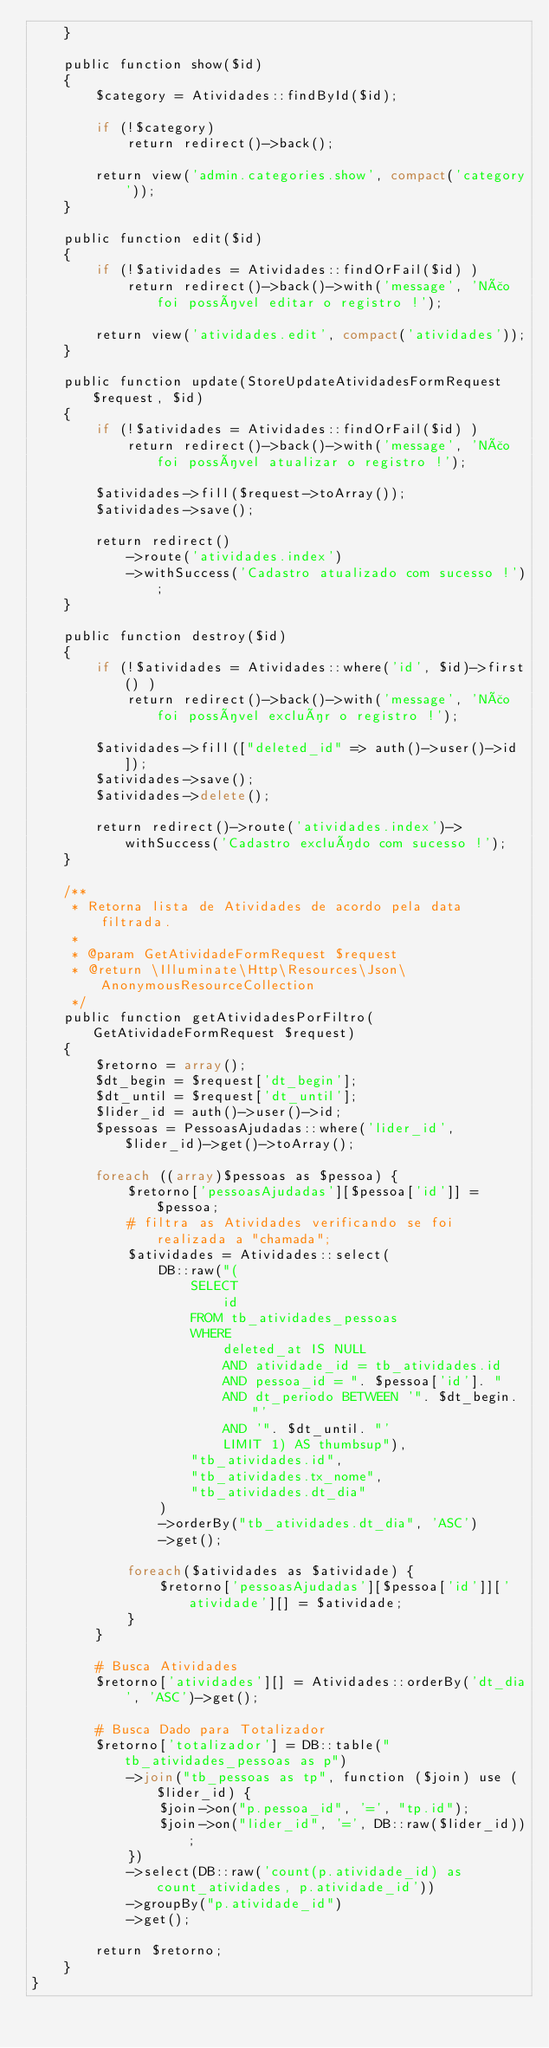<code> <loc_0><loc_0><loc_500><loc_500><_PHP_>    }

    public function show($id)
    {
        $category = Atividades::findById($id);

        if (!$category)
            return redirect()->back();

        return view('admin.categories.show', compact('category'));
    }

    public function edit($id)
    {
        if (!$atividades = Atividades::findOrFail($id) )
            return redirect()->back()->with('message', 'Não foi possível editar o registro !');

        return view('atividades.edit', compact('atividades'));
    }

    public function update(StoreUpdateAtividadesFormRequest $request, $id)
    {
        if (!$atividades = Atividades::findOrFail($id) )
            return redirect()->back()->with('message', 'Não foi possível atualizar o registro !');

        $atividades->fill($request->toArray());
        $atividades->save();

        return redirect()
            ->route('atividades.index')
            ->withSuccess('Cadastro atualizado com sucesso !');
    }

    public function destroy($id)
    {
        if (!$atividades = Atividades::where('id', $id)->first() )
            return redirect()->back()->with('message', 'Não foi possível excluír o registro !');

        $atividades->fill(["deleted_id" => auth()->user()->id]);
        $atividades->save();
        $atividades->delete();

        return redirect()->route('atividades.index')->withSuccess('Cadastro excluído com sucesso !');
    }

    /**
     * Retorna lista de Atividades de acordo pela data filtrada.
     *
     * @param GetAtividadeFormRequest $request
     * @return \Illuminate\Http\Resources\Json\AnonymousResourceCollection
     */
    public function getAtividadesPorFiltro(GetAtividadeFormRequest $request)
    {
        $retorno = array();
        $dt_begin = $request['dt_begin'];
        $dt_until = $request['dt_until'];
        $lider_id = auth()->user()->id;
        $pessoas = PessoasAjudadas::where('lider_id', $lider_id)->get()->toArray();

        foreach ((array)$pessoas as $pessoa) {
            $retorno['pessoasAjudadas'][$pessoa['id']] = $pessoa;
            # filtra as Atividades verificando se foi realizada a "chamada";
            $atividades = Atividades::select(
                DB::raw("(
                    SELECT
                        id
                    FROM tb_atividades_pessoas
                    WHERE
                        deleted_at IS NULL
                        AND atividade_id = tb_atividades.id
                        AND pessoa_id = ". $pessoa['id']. "
                        AND dt_periodo BETWEEN '". $dt_begin. "'
                        AND '". $dt_until. "'
                        LIMIT 1) AS thumbsup"),
                    "tb_atividades.id",
                    "tb_atividades.tx_nome",
                    "tb_atividades.dt_dia"
                )
                ->orderBy("tb_atividades.dt_dia", 'ASC')
                ->get();

            foreach($atividades as $atividade) {
                $retorno['pessoasAjudadas'][$pessoa['id']]['atividade'][] = $atividade;
            }
        }

        # Busca Atividades
        $retorno['atividades'][] = Atividades::orderBy('dt_dia', 'ASC')->get();

        # Busca Dado para Totalizador
        $retorno['totalizador'] = DB::table("tb_atividades_pessoas as p")
            ->join("tb_pessoas as tp", function ($join) use ($lider_id) {
                $join->on("p.pessoa_id", '=', "tp.id");
                $join->on("lider_id", '=', DB::raw($lider_id));
            })
            ->select(DB::raw('count(p.atividade_id) as count_atividades, p.atividade_id'))
            ->groupBy("p.atividade_id")
            ->get();

        return $retorno;
    }
}
</code> 